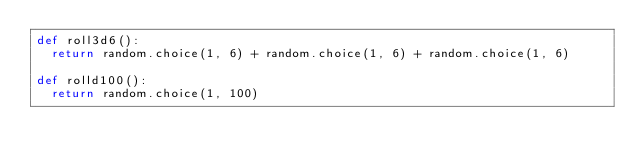Convert code to text. <code><loc_0><loc_0><loc_500><loc_500><_Python_>def roll3d6():
  return random.choice(1, 6) + random.choice(1, 6) + random.choice(1, 6)

def rolld100():
  return random.choice(1, 100)
</code> 